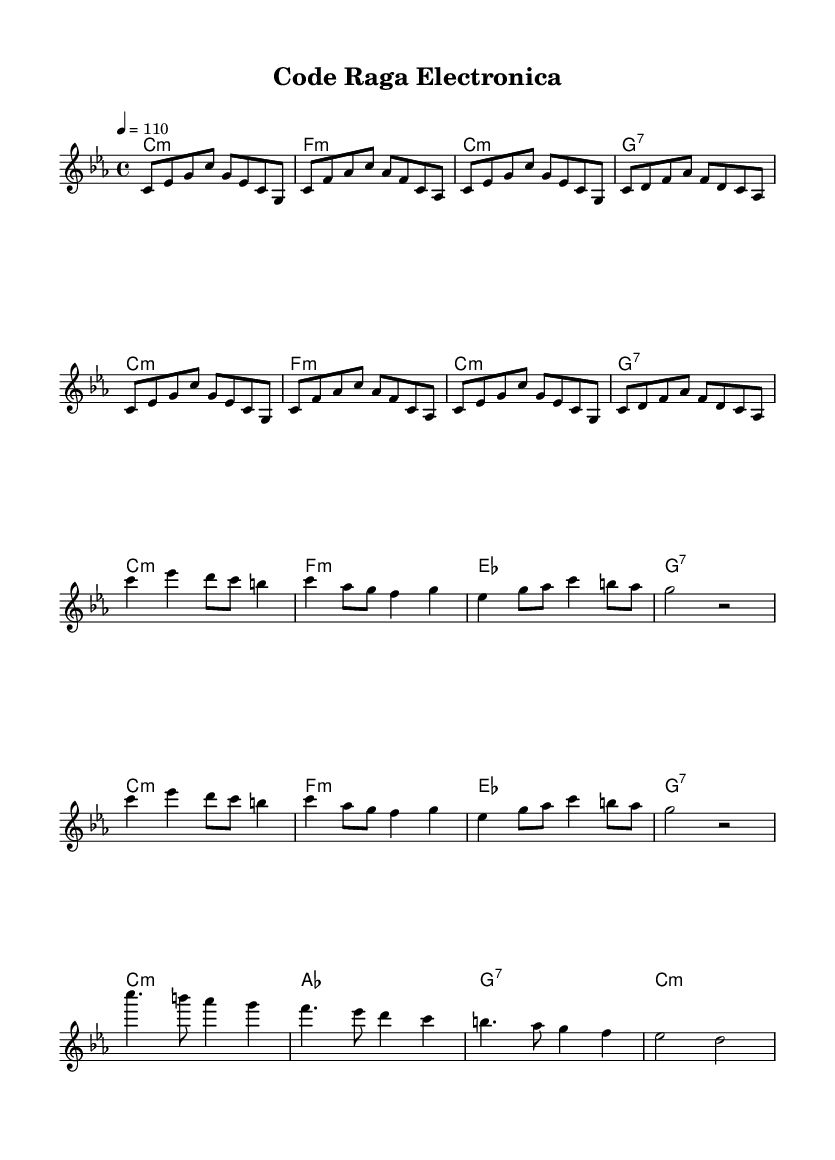What is the key signature of this music? The key signature is C minor, which has three flats (B, E, and A). This is indicated in the global section at the start of the score.
Answer: C minor What is the time signature of this music? The time signature is 4/4, meaning there are four beats per measure. This is specified clearly in the global section of the score.
Answer: 4/4 What is the tempo marking indicated in this sheet music? The tempo marking is 4 = 110, which means there are 110 beats per minute. This is found in the global section of the score.
Answer: 110 How many times is the intro repeated? The intro section is repeated 2 times as indicated by the repeat unfold marker before the melody section.
Answer: 2 What is the first chord of the verse? The first chord of the verse is C minor, as indicated in the harmonies section beneath the corresponding melody line.
Answer: C minor What type of musical fusion is represented in this piece? The piece represents a fusion of Indian classical ragas with electronic beats, as implied by the title "Code Raga Electronica" and the blending of harmonies and rhythms typical in world music.
Answer: Indian classical ragas and electronic beats In which section do we see the use of a dominant seventh chord? The dominant seventh chord is used in the chorus section, which is indicated by the "g1:7" notation in the harmonies. This notation signifies the use of a dominant seventh chord based on the note G.
Answer: Chorus 